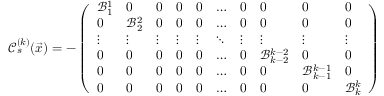Convert formula to latex. <formula><loc_0><loc_0><loc_500><loc_500>\mathcal { C } _ { s } ^ { ( k ) } ( \vec { x } ) = - \left ( \begin{array} { l l l l l l l l l l } { \mathcal { B } _ { 1 } ^ { 1 } } & { 0 } & { 0 } & { 0 } & { 0 } & { \dots } & { 0 } & { 0 } & { 0 } & { 0 } \\ { 0 } & { \mathcal { B } _ { 2 } ^ { 2 } } & { 0 } & { 0 } & { 0 } & { \dots } & { 0 } & { 0 } & { 0 } & { 0 } \\ { \vdots } & { \vdots } & { \vdots } & { \vdots } & { \vdots } & { \ddots } & { \vdots } & { \vdots } & { \vdots } & { \vdots } \\ { 0 } & { 0 } & { 0 } & { 0 } & { 0 } & { \dots } & { 0 } & { \mathcal { B } _ { k - 2 } ^ { k - 2 } } & { 0 } & { 0 } \\ { 0 } & { 0 } & { 0 } & { 0 } & { 0 } & { \dots } & { 0 } & { 0 } & { \mathcal { B } _ { k - 1 } ^ { k - 1 } } & { 0 } \\ { 0 } & { 0 } & { 0 } & { 0 } & { 0 } & { \dots } & { 0 } & { 0 } & { 0 } & { \mathcal { B } _ { k } ^ { k } } \end{array} \right )</formula> 